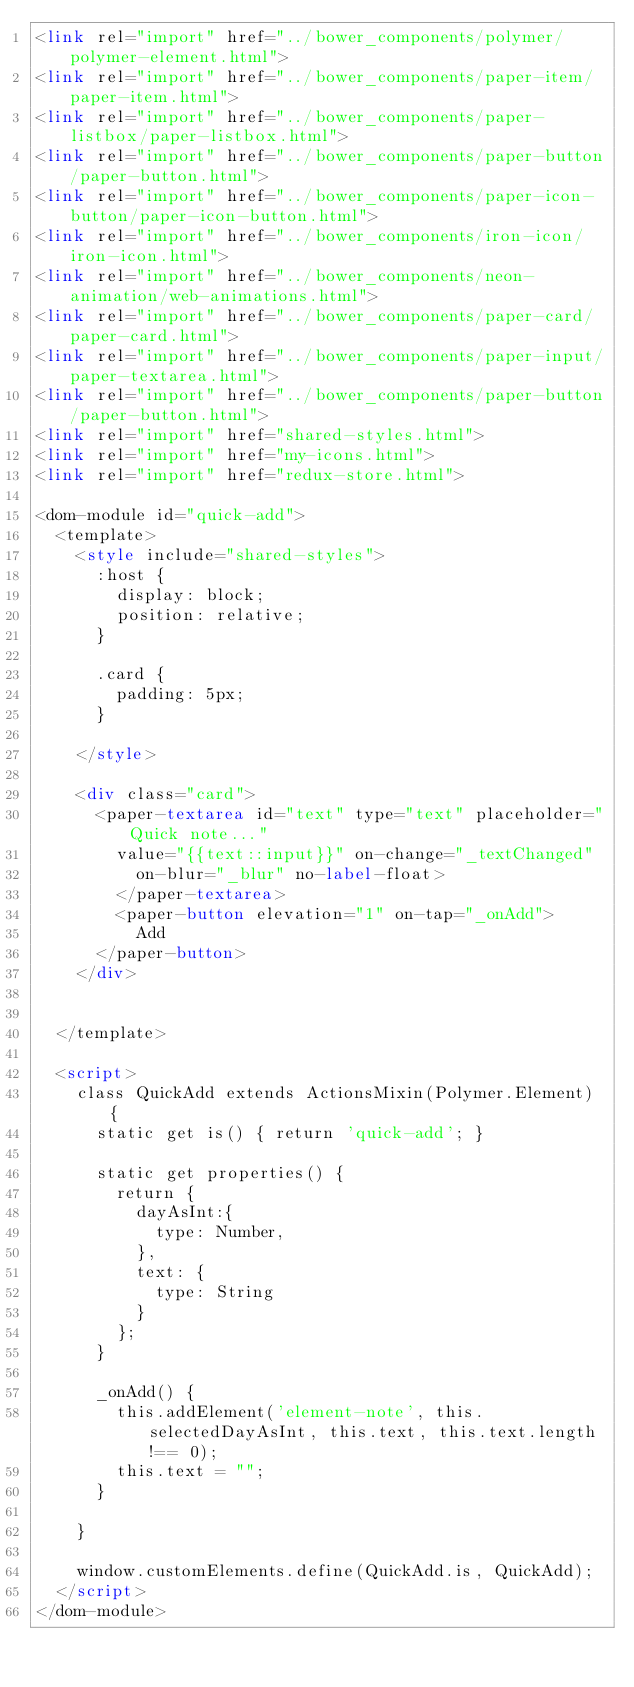<code> <loc_0><loc_0><loc_500><loc_500><_HTML_><link rel="import" href="../bower_components/polymer/polymer-element.html">
<link rel="import" href="../bower_components/paper-item/paper-item.html">
<link rel="import" href="../bower_components/paper-listbox/paper-listbox.html">
<link rel="import" href="../bower_components/paper-button/paper-button.html">
<link rel="import" href="../bower_components/paper-icon-button/paper-icon-button.html">
<link rel="import" href="../bower_components/iron-icon/iron-icon.html">
<link rel="import" href="../bower_components/neon-animation/web-animations.html">
<link rel="import" href="../bower_components/paper-card/paper-card.html">
<link rel="import" href="../bower_components/paper-input/paper-textarea.html">
<link rel="import" href="../bower_components/paper-button/paper-button.html">
<link rel="import" href="shared-styles.html">
<link rel="import" href="my-icons.html">
<link rel="import" href="redux-store.html">

<dom-module id="quick-add">
  <template>
    <style include="shared-styles">
      :host {
        display: block;
        position: relative;
      }
      
      .card {
        padding: 5px;
      }

    </style>

    <div class="card">
      <paper-textarea id="text" type="text" placeholder="Quick note..." 
        value="{{text::input}}" on-change="_textChanged"
          on-blur="_blur" no-label-float>
        </paper-textarea>
        <paper-button elevation="1" on-tap="_onAdd">
          Add
      </paper-button>
    </div>

    
  </template>

  <script>
    class QuickAdd extends ActionsMixin(Polymer.Element) {
      static get is() { return 'quick-add'; }

      static get properties() {
        return {
          dayAsInt:{
            type: Number,
          },
          text: {
            type: String
          }
        };
      }

      _onAdd() {
        this.addElement('element-note', this.selectedDayAsInt, this.text, this.text.length !== 0);
        this.text = "";
      }

    }

    window.customElements.define(QuickAdd.is, QuickAdd);
  </script>
</dom-module>
</code> 